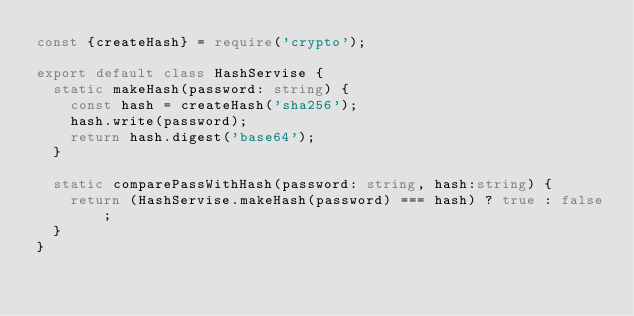<code> <loc_0><loc_0><loc_500><loc_500><_TypeScript_>const {createHash} = require('crypto');

export default class HashServise {
  static makeHash(password: string) {
    const hash = createHash('sha256');
    hash.write(password);
    return hash.digest('base64');
  }

  static comparePassWithHash(password: string, hash:string) {
    return (HashServise.makeHash(password) === hash) ? true : false;
  }
}</code> 